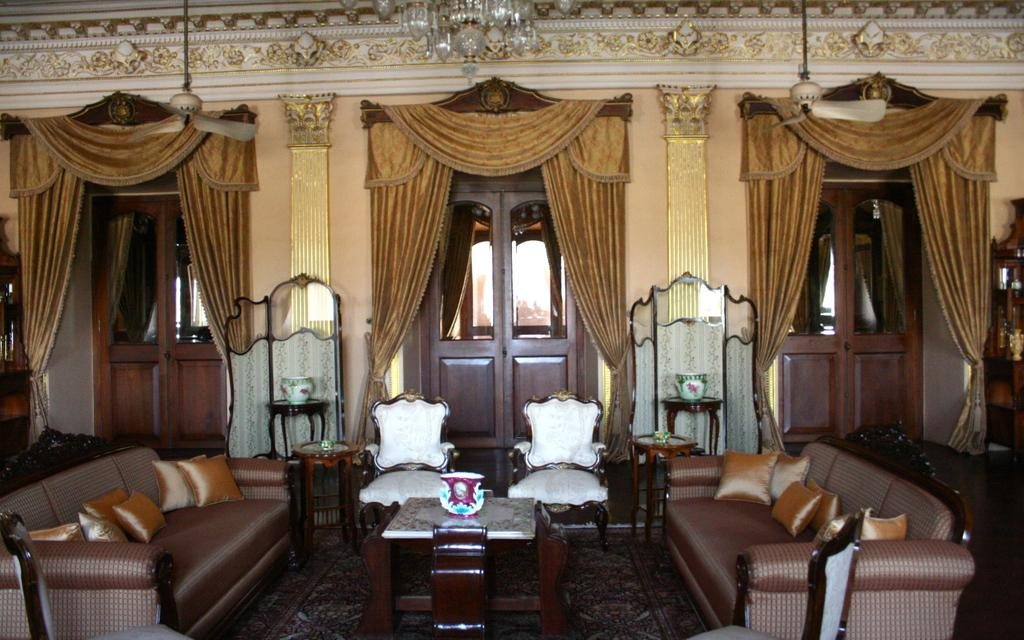What type of furniture is present in the room? There is a table, a sofa, and chairs in the room. What can be used to cover the doors or windows in the room? There are doors and curtains in the room. What is hanging from the ceiling in the room? There is a chandelier at the top of the room. What type of popcorn is being served on the table in the room? There is no popcorn present in the image; it only shows a table, sofa, chairs, doors, curtains, and a chandelier. What type of writing can be seen on the curtains in the room? There is no writing visible on the curtains in the image. 